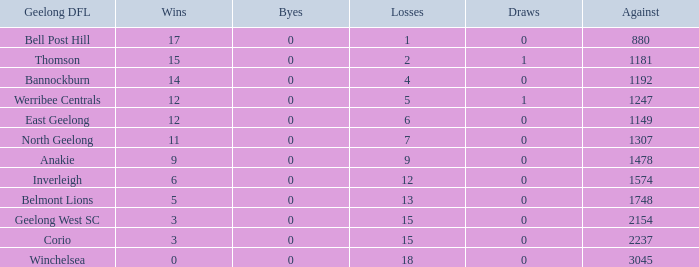In geelong dfl, when bell post hill has a negative number of draws, what is their average loss? None. 